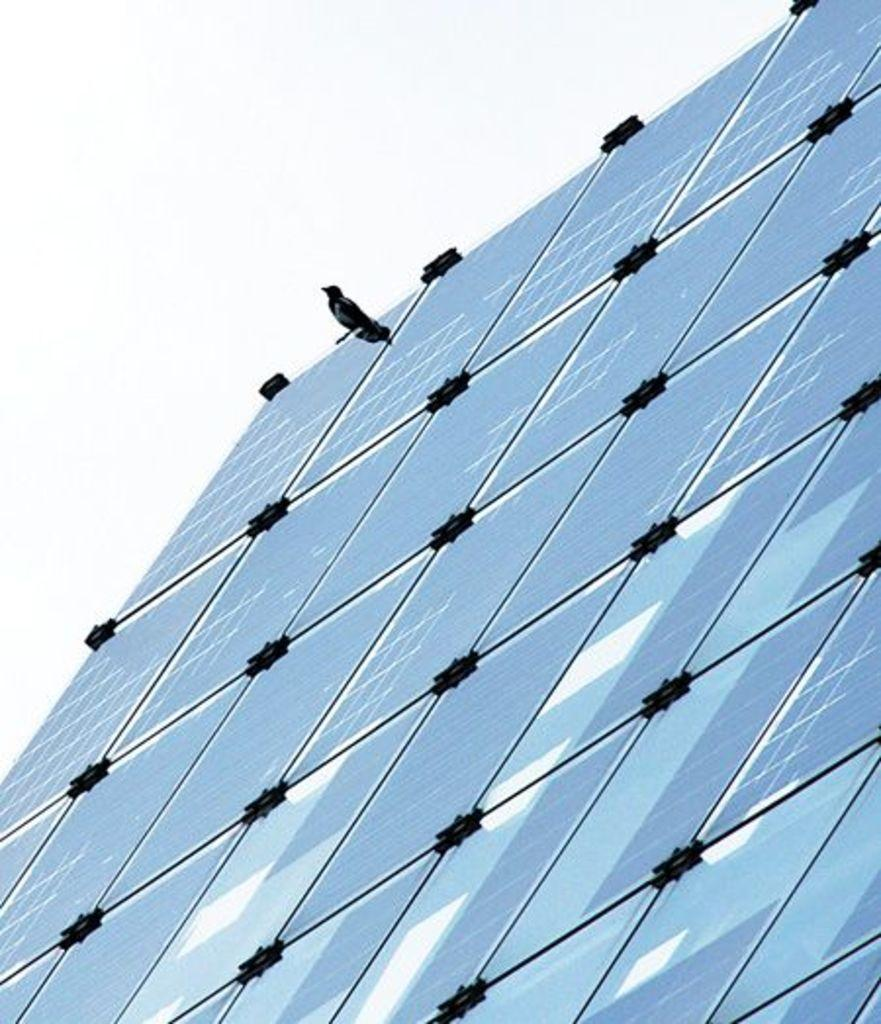What type of structure can be seen in the image? There is a glass window in the image. What is sitting on the window? A bird is sitting on the window. What can be seen in the background of the image? The sky is visible in the background of the image. What effect does the bird's presence have on the window's ability to keep out the wind? The image does not provide information about the window's ability to keep out the wind, nor does it show any wind. Therefore, we cannot determine the effect of the bird's presence on the window's function. 